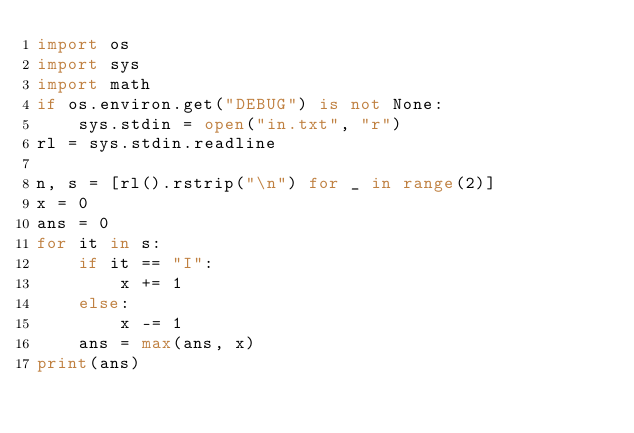Convert code to text. <code><loc_0><loc_0><loc_500><loc_500><_Python_>import os
import sys
import math
if os.environ.get("DEBUG") is not None:
    sys.stdin = open("in.txt", "r")
rl = sys.stdin.readline

n, s = [rl().rstrip("\n") for _ in range(2)]
x = 0
ans = 0
for it in s:
    if it == "I":
        x += 1
    else:
        x -= 1
    ans = max(ans, x)
print(ans)</code> 